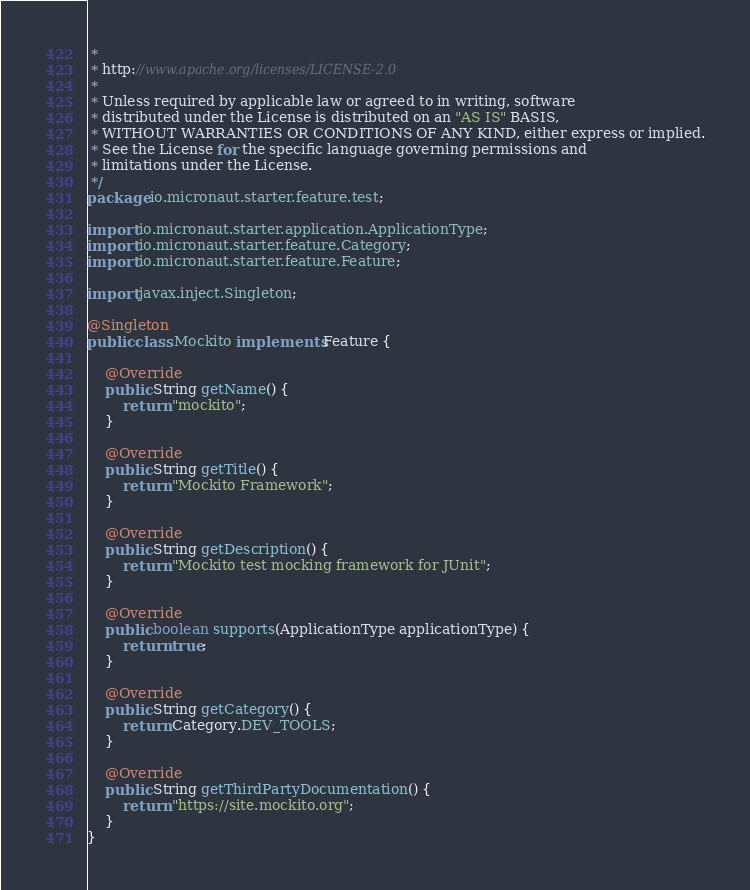<code> <loc_0><loc_0><loc_500><loc_500><_Java_> *
 * http://www.apache.org/licenses/LICENSE-2.0
 *
 * Unless required by applicable law or agreed to in writing, software
 * distributed under the License is distributed on an "AS IS" BASIS,
 * WITHOUT WARRANTIES OR CONDITIONS OF ANY KIND, either express or implied.
 * See the License for the specific language governing permissions and
 * limitations under the License.
 */
package io.micronaut.starter.feature.test;

import io.micronaut.starter.application.ApplicationType;
import io.micronaut.starter.feature.Category;
import io.micronaut.starter.feature.Feature;

import javax.inject.Singleton;

@Singleton
public class Mockito implements Feature {

    @Override
    public String getName() {
        return "mockito";
    }

    @Override
    public String getTitle() {
        return "Mockito Framework";
    }

    @Override
    public String getDescription() {
        return "Mockito test mocking framework for JUnit";
    }

    @Override
    public boolean supports(ApplicationType applicationType) {
        return true;
    }

    @Override
    public String getCategory() {
        return Category.DEV_TOOLS;
    }

    @Override
    public String getThirdPartyDocumentation() {
        return "https://site.mockito.org";
    }
}
</code> 